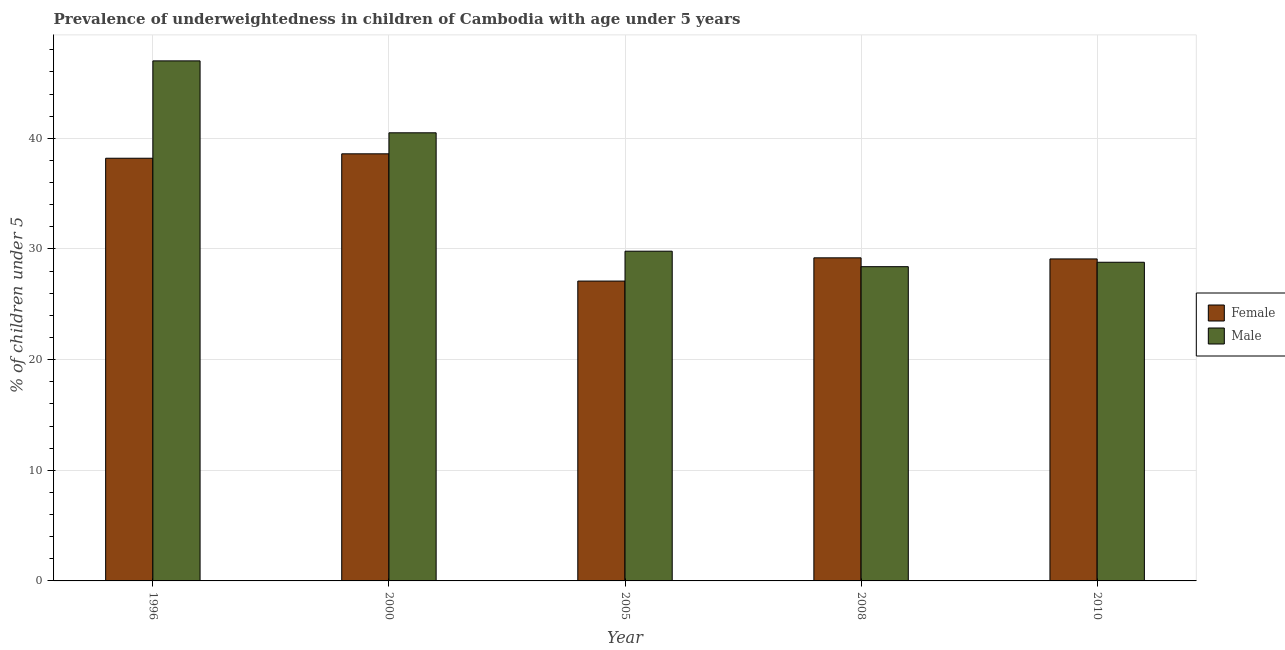How many different coloured bars are there?
Provide a succinct answer. 2. Are the number of bars per tick equal to the number of legend labels?
Provide a short and direct response. Yes. Are the number of bars on each tick of the X-axis equal?
Offer a very short reply. Yes. In how many cases, is the number of bars for a given year not equal to the number of legend labels?
Your answer should be very brief. 0. What is the percentage of underweighted male children in 2008?
Keep it short and to the point. 28.4. Across all years, what is the maximum percentage of underweighted female children?
Offer a terse response. 38.6. Across all years, what is the minimum percentage of underweighted male children?
Your response must be concise. 28.4. In which year was the percentage of underweighted female children maximum?
Provide a succinct answer. 2000. What is the total percentage of underweighted female children in the graph?
Your response must be concise. 162.2. What is the difference between the percentage of underweighted female children in 2005 and that in 2010?
Provide a short and direct response. -2. What is the difference between the percentage of underweighted male children in 2005 and the percentage of underweighted female children in 2000?
Provide a succinct answer. -10.7. What is the average percentage of underweighted female children per year?
Offer a very short reply. 32.44. In how many years, is the percentage of underweighted male children greater than 12 %?
Make the answer very short. 5. What is the ratio of the percentage of underweighted female children in 1996 to that in 2000?
Keep it short and to the point. 0.99. What is the difference between the highest and the second highest percentage of underweighted female children?
Ensure brevity in your answer.  0.4. What is the difference between the highest and the lowest percentage of underweighted male children?
Your answer should be very brief. 18.6. In how many years, is the percentage of underweighted female children greater than the average percentage of underweighted female children taken over all years?
Provide a succinct answer. 2. Is the sum of the percentage of underweighted male children in 1996 and 2005 greater than the maximum percentage of underweighted female children across all years?
Offer a very short reply. Yes. What does the 1st bar from the right in 2008 represents?
Ensure brevity in your answer.  Male. How many bars are there?
Make the answer very short. 10. How many years are there in the graph?
Ensure brevity in your answer.  5. What is the difference between two consecutive major ticks on the Y-axis?
Ensure brevity in your answer.  10. Are the values on the major ticks of Y-axis written in scientific E-notation?
Offer a very short reply. No. Where does the legend appear in the graph?
Offer a very short reply. Center right. What is the title of the graph?
Give a very brief answer. Prevalence of underweightedness in children of Cambodia with age under 5 years. Does "Register a business" appear as one of the legend labels in the graph?
Your answer should be very brief. No. What is the label or title of the Y-axis?
Give a very brief answer.  % of children under 5. What is the  % of children under 5 in Female in 1996?
Offer a very short reply. 38.2. What is the  % of children under 5 of Female in 2000?
Offer a very short reply. 38.6. What is the  % of children under 5 in Male in 2000?
Keep it short and to the point. 40.5. What is the  % of children under 5 in Female in 2005?
Make the answer very short. 27.1. What is the  % of children under 5 in Male in 2005?
Your answer should be very brief. 29.8. What is the  % of children under 5 of Female in 2008?
Provide a short and direct response. 29.2. What is the  % of children under 5 of Male in 2008?
Your response must be concise. 28.4. What is the  % of children under 5 in Female in 2010?
Provide a succinct answer. 29.1. What is the  % of children under 5 of Male in 2010?
Provide a short and direct response. 28.8. Across all years, what is the maximum  % of children under 5 of Female?
Keep it short and to the point. 38.6. Across all years, what is the maximum  % of children under 5 in Male?
Ensure brevity in your answer.  47. Across all years, what is the minimum  % of children under 5 in Female?
Offer a terse response. 27.1. Across all years, what is the minimum  % of children under 5 of Male?
Your answer should be very brief. 28.4. What is the total  % of children under 5 in Female in the graph?
Keep it short and to the point. 162.2. What is the total  % of children under 5 in Male in the graph?
Offer a terse response. 174.5. What is the difference between the  % of children under 5 of Male in 1996 and that in 2000?
Ensure brevity in your answer.  6.5. What is the difference between the  % of children under 5 in Male in 1996 and that in 2008?
Your answer should be very brief. 18.6. What is the difference between the  % of children under 5 in Male in 1996 and that in 2010?
Give a very brief answer. 18.2. What is the difference between the  % of children under 5 of Female in 2000 and that in 2005?
Provide a short and direct response. 11.5. What is the difference between the  % of children under 5 in Female in 2000 and that in 2008?
Keep it short and to the point. 9.4. What is the difference between the  % of children under 5 in Female in 2005 and that in 2008?
Your answer should be very brief. -2.1. What is the difference between the  % of children under 5 of Female in 2005 and that in 2010?
Your answer should be compact. -2. What is the difference between the  % of children under 5 in Female in 1996 and the  % of children under 5 in Male in 2000?
Ensure brevity in your answer.  -2.3. What is the difference between the  % of children under 5 in Female in 1996 and the  % of children under 5 in Male in 2005?
Provide a succinct answer. 8.4. What is the difference between the  % of children under 5 of Female in 2000 and the  % of children under 5 of Male in 2010?
Keep it short and to the point. 9.8. What is the difference between the  % of children under 5 in Female in 2008 and the  % of children under 5 in Male in 2010?
Provide a short and direct response. 0.4. What is the average  % of children under 5 in Female per year?
Your answer should be compact. 32.44. What is the average  % of children under 5 in Male per year?
Give a very brief answer. 34.9. In the year 1996, what is the difference between the  % of children under 5 in Female and  % of children under 5 in Male?
Ensure brevity in your answer.  -8.8. In the year 2005, what is the difference between the  % of children under 5 in Female and  % of children under 5 in Male?
Your answer should be compact. -2.7. In the year 2008, what is the difference between the  % of children under 5 of Female and  % of children under 5 of Male?
Offer a terse response. 0.8. What is the ratio of the  % of children under 5 of Female in 1996 to that in 2000?
Ensure brevity in your answer.  0.99. What is the ratio of the  % of children under 5 in Male in 1996 to that in 2000?
Ensure brevity in your answer.  1.16. What is the ratio of the  % of children under 5 in Female in 1996 to that in 2005?
Your answer should be very brief. 1.41. What is the ratio of the  % of children under 5 of Male in 1996 to that in 2005?
Your answer should be very brief. 1.58. What is the ratio of the  % of children under 5 of Female in 1996 to that in 2008?
Your response must be concise. 1.31. What is the ratio of the  % of children under 5 of Male in 1996 to that in 2008?
Offer a very short reply. 1.65. What is the ratio of the  % of children under 5 in Female in 1996 to that in 2010?
Ensure brevity in your answer.  1.31. What is the ratio of the  % of children under 5 in Male in 1996 to that in 2010?
Your response must be concise. 1.63. What is the ratio of the  % of children under 5 of Female in 2000 to that in 2005?
Keep it short and to the point. 1.42. What is the ratio of the  % of children under 5 of Male in 2000 to that in 2005?
Provide a short and direct response. 1.36. What is the ratio of the  % of children under 5 of Female in 2000 to that in 2008?
Your answer should be very brief. 1.32. What is the ratio of the  % of children under 5 in Male in 2000 to that in 2008?
Give a very brief answer. 1.43. What is the ratio of the  % of children under 5 in Female in 2000 to that in 2010?
Provide a succinct answer. 1.33. What is the ratio of the  % of children under 5 in Male in 2000 to that in 2010?
Offer a terse response. 1.41. What is the ratio of the  % of children under 5 of Female in 2005 to that in 2008?
Provide a succinct answer. 0.93. What is the ratio of the  % of children under 5 of Male in 2005 to that in 2008?
Keep it short and to the point. 1.05. What is the ratio of the  % of children under 5 of Female in 2005 to that in 2010?
Offer a very short reply. 0.93. What is the ratio of the  % of children under 5 of Male in 2005 to that in 2010?
Keep it short and to the point. 1.03. What is the ratio of the  % of children under 5 of Female in 2008 to that in 2010?
Provide a short and direct response. 1. What is the ratio of the  % of children under 5 of Male in 2008 to that in 2010?
Ensure brevity in your answer.  0.99. 